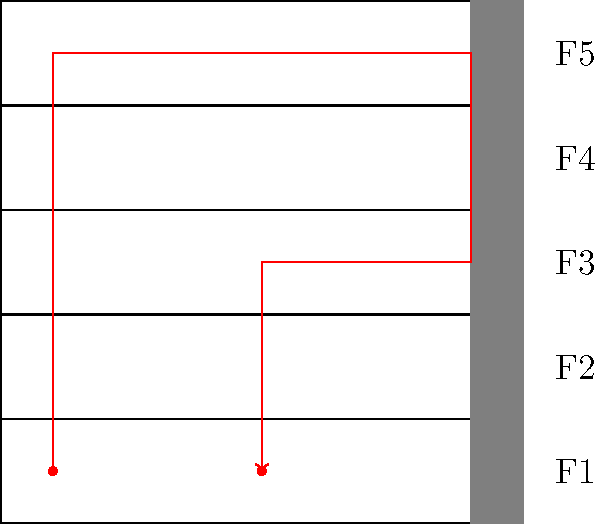As the receptionist at Dunder Mifflin, you're tasked with delivering paper supplies to different floors of a 5-story office building. Starting from the first floor (F1), you need to visit floors F5, F3, and F2 in the most efficient order before returning to F1. The building has one elevator located on the right side. What is the minimum number of floor changes required to complete this delivery route? Let's approach this step-by-step, channeling our inner Dwight Schrute for maximum efficiency:

1) We start at F1 and need to visit F5, F3, and F2 before returning to F1.

2) The most efficient route would be to go up first, then work our way down:
   F1 → F5 → F3 → F2 → F1

3) Let's count the floor changes:
   - F1 to F5: 4 floor changes
   - F5 to F3: 2 floor changes
   - F3 to F2: 1 floor change
   - F2 to F1: 1 floor change

4) Total floor changes: $4 + 2 + 1 + 1 = 8$

5) As Michael Scott would say, "That's what she said!" Wait, no, that doesn't apply here. Let's stick to, "Sometimes I'll start a sentence and I don't even know where it's going. I just hope I find it along the way." But in this case, we found our answer!

Therefore, the minimum number of floor changes required is 8.
Answer: 8 floor changes 